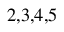Convert formula to latex. <formula><loc_0><loc_0><loc_500><loc_500>^ { 2 , 3 , 4 , 5 }</formula> 